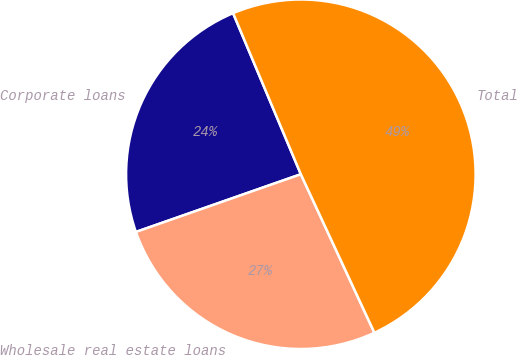Convert chart to OTSL. <chart><loc_0><loc_0><loc_500><loc_500><pie_chart><fcel>Corporate loans<fcel>Wholesale real estate loans<fcel>Total<nl><fcel>24.02%<fcel>26.56%<fcel>49.42%<nl></chart> 